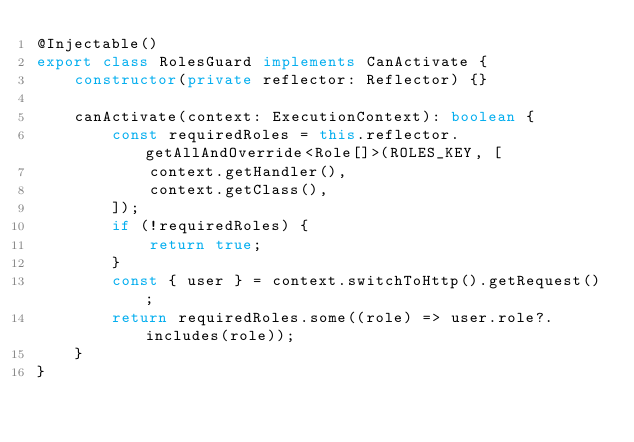<code> <loc_0><loc_0><loc_500><loc_500><_TypeScript_>@Injectable()
export class RolesGuard implements CanActivate {
    constructor(private reflector: Reflector) {}

    canActivate(context: ExecutionContext): boolean {
        const requiredRoles = this.reflector.getAllAndOverride<Role[]>(ROLES_KEY, [
            context.getHandler(),
            context.getClass(),
        ]);
        if (!requiredRoles) {
            return true;
        }
        const { user } = context.switchToHttp().getRequest();
        return requiredRoles.some((role) => user.role?.includes(role));
    }
}</code> 